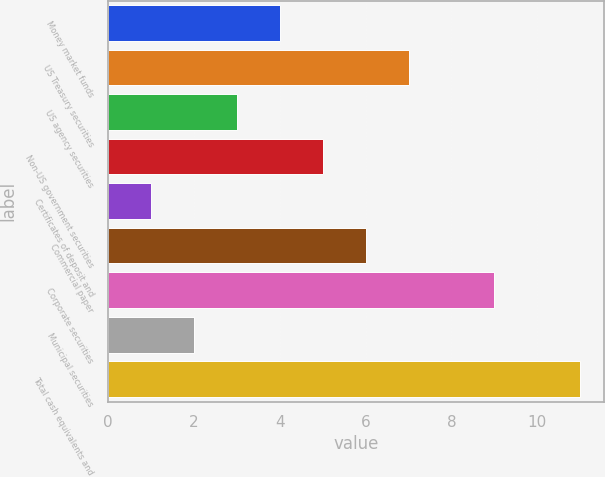Convert chart. <chart><loc_0><loc_0><loc_500><loc_500><bar_chart><fcel>Money market funds<fcel>US Treasury securities<fcel>US agency securities<fcel>Non-US government securities<fcel>Certificates of deposit and<fcel>Commercial paper<fcel>Corporate securities<fcel>Municipal securities<fcel>Total cash equivalents and<nl><fcel>4<fcel>7<fcel>3<fcel>5<fcel>1<fcel>6<fcel>9<fcel>2<fcel>11<nl></chart> 